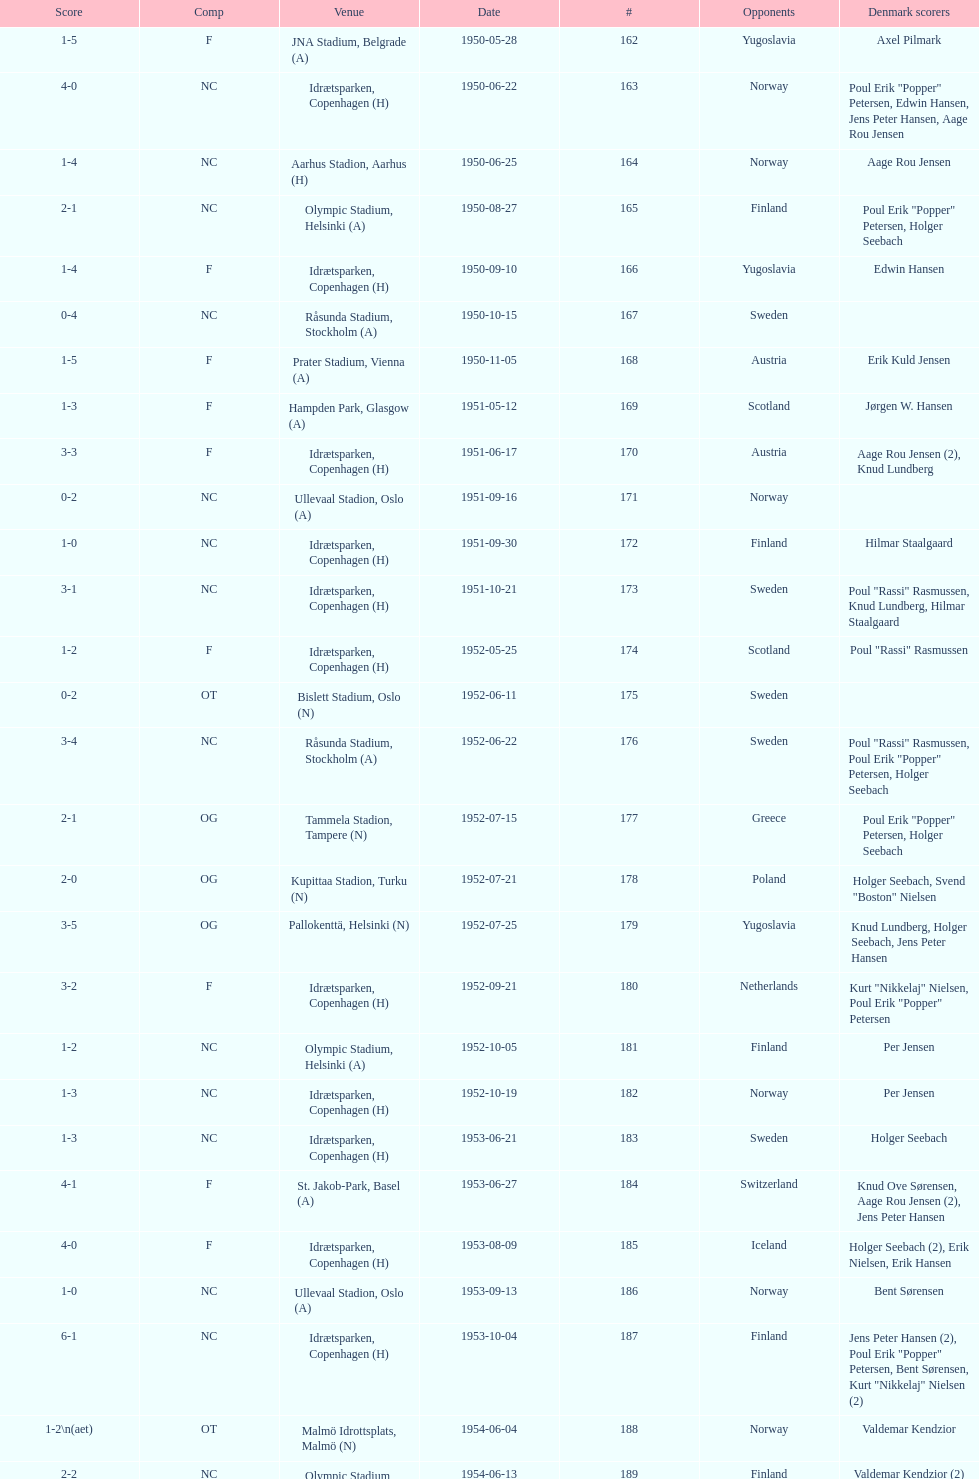Which total score was higher, game #163 or #181? 163. 